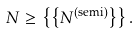Convert formula to latex. <formula><loc_0><loc_0><loc_500><loc_500>N \geq \left \{ \left \{ N ^ { \text {(semi)} } \right \} \right \} .</formula> 